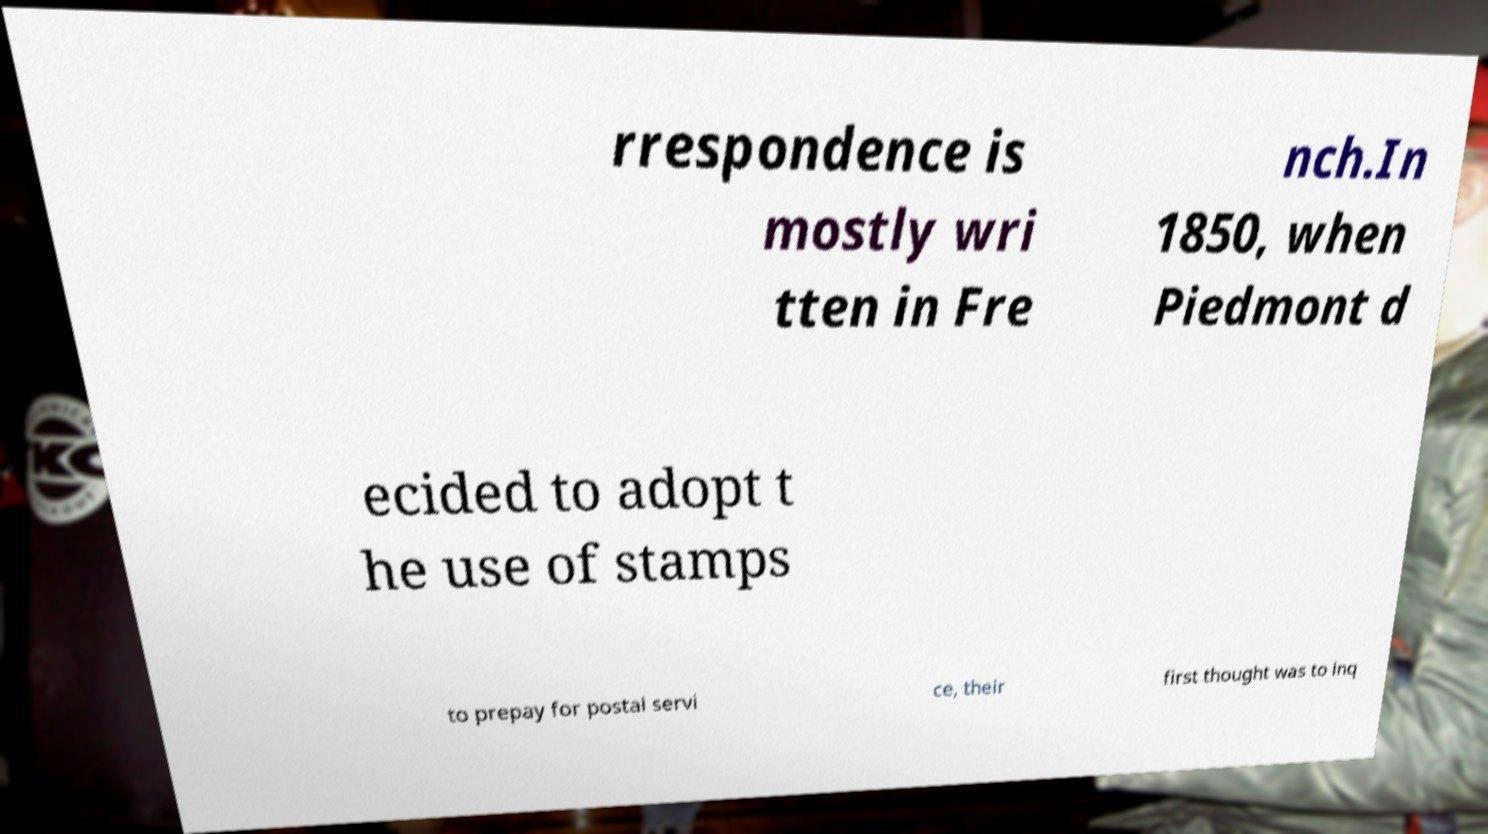I need the written content from this picture converted into text. Can you do that? rrespondence is mostly wri tten in Fre nch.In 1850, when Piedmont d ecided to adopt t he use of stamps to prepay for postal servi ce, their first thought was to inq 